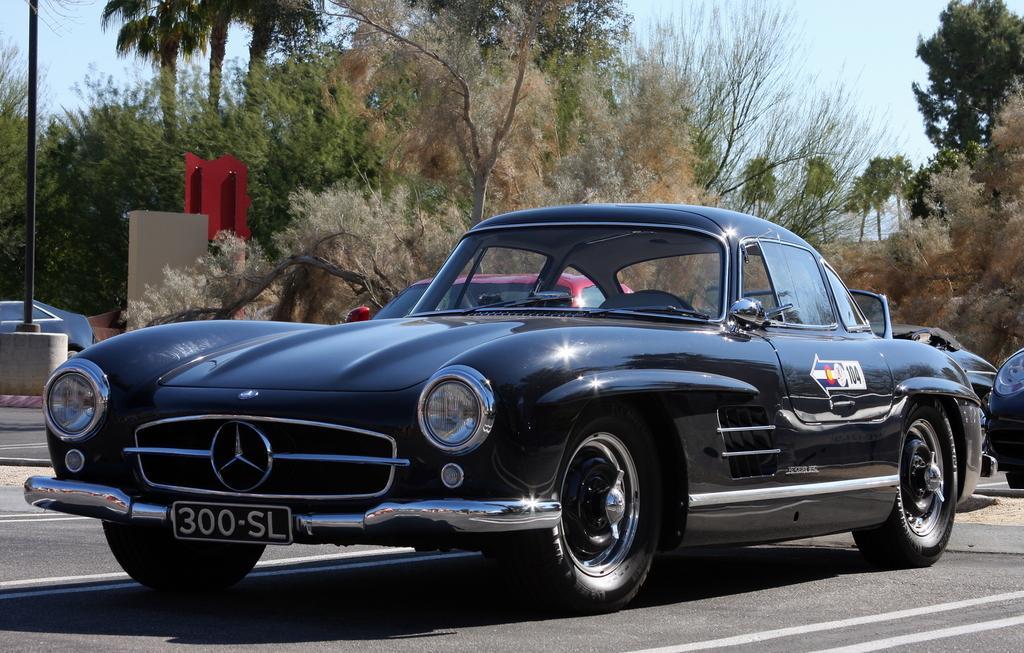Could you give a brief overview of what you see in this image? In this picture we can see some vehicles on the road and behind the vehicles there is a pole, a red board, trees and the sky. 